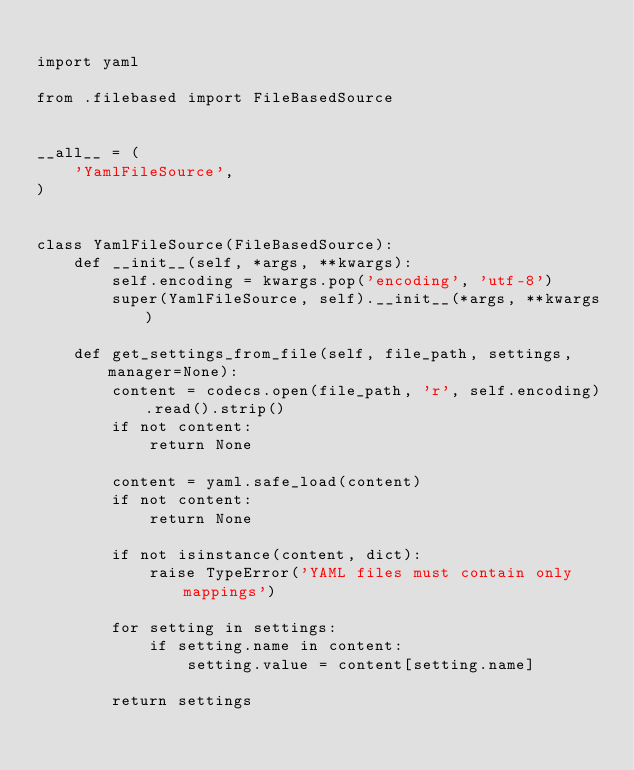Convert code to text. <code><loc_0><loc_0><loc_500><loc_500><_Python_>
import yaml

from .filebased import FileBasedSource


__all__ = (
    'YamlFileSource',
)


class YamlFileSource(FileBasedSource):
    def __init__(self, *args, **kwargs):
        self.encoding = kwargs.pop('encoding', 'utf-8')
        super(YamlFileSource, self).__init__(*args, **kwargs)

    def get_settings_from_file(self, file_path, settings, manager=None):
        content = codecs.open(file_path, 'r', self.encoding).read().strip()
        if not content:
            return None

        content = yaml.safe_load(content)
        if not content:
            return None

        if not isinstance(content, dict):
            raise TypeError('YAML files must contain only mappings')

        for setting in settings:
            if setting.name in content:
                setting.value = content[setting.name]

        return settings
</code> 